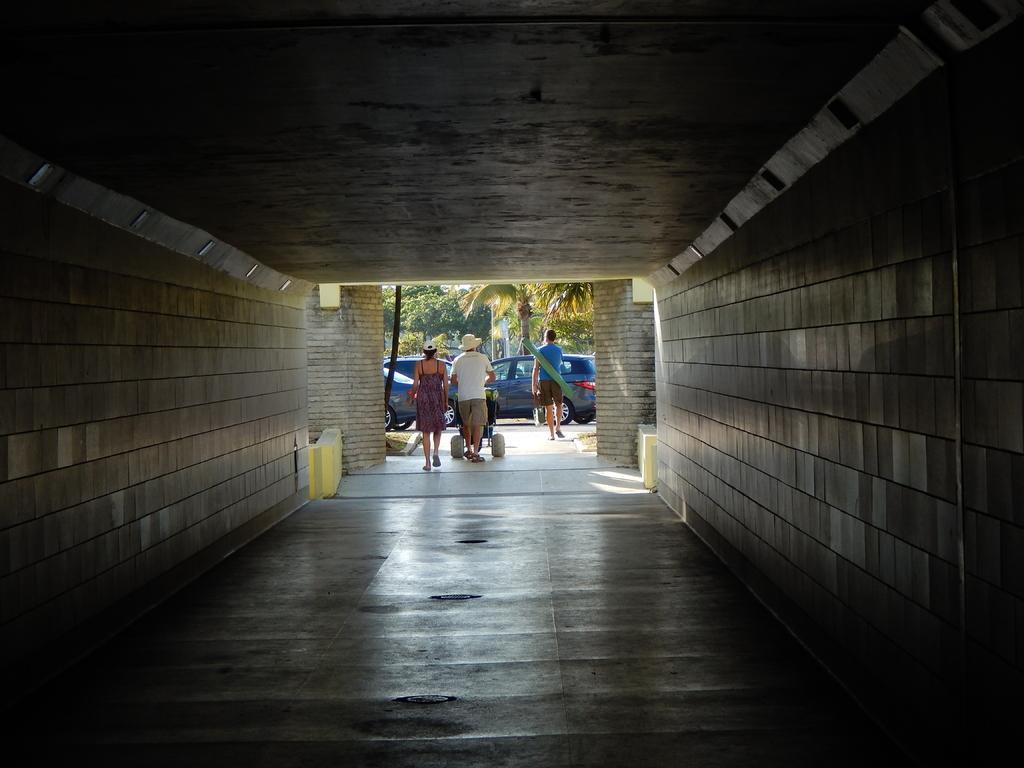Could you give a brief overview of what you see in this image? In the picture I can see the subway. I can see three persons walking on the floor and I can see a man carrying a baby stroller. In the background, I can see the cars and trees. 